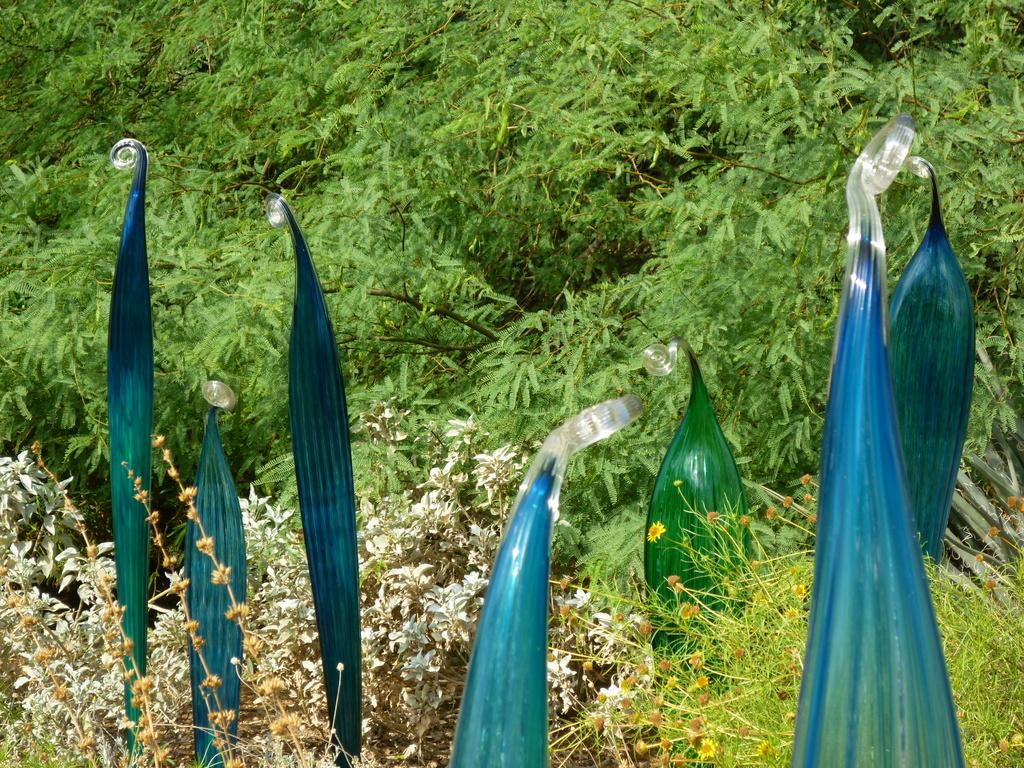What can be seen in the foreground of the image? There are leaves in the foreground of the image. What type of environment is depicted in the image? There is greenery around the area of the image, suggesting a natural setting. How many dimes are scattered among the leaves in the image? There are no dimes present in the image; it only features leaves and greenery. 